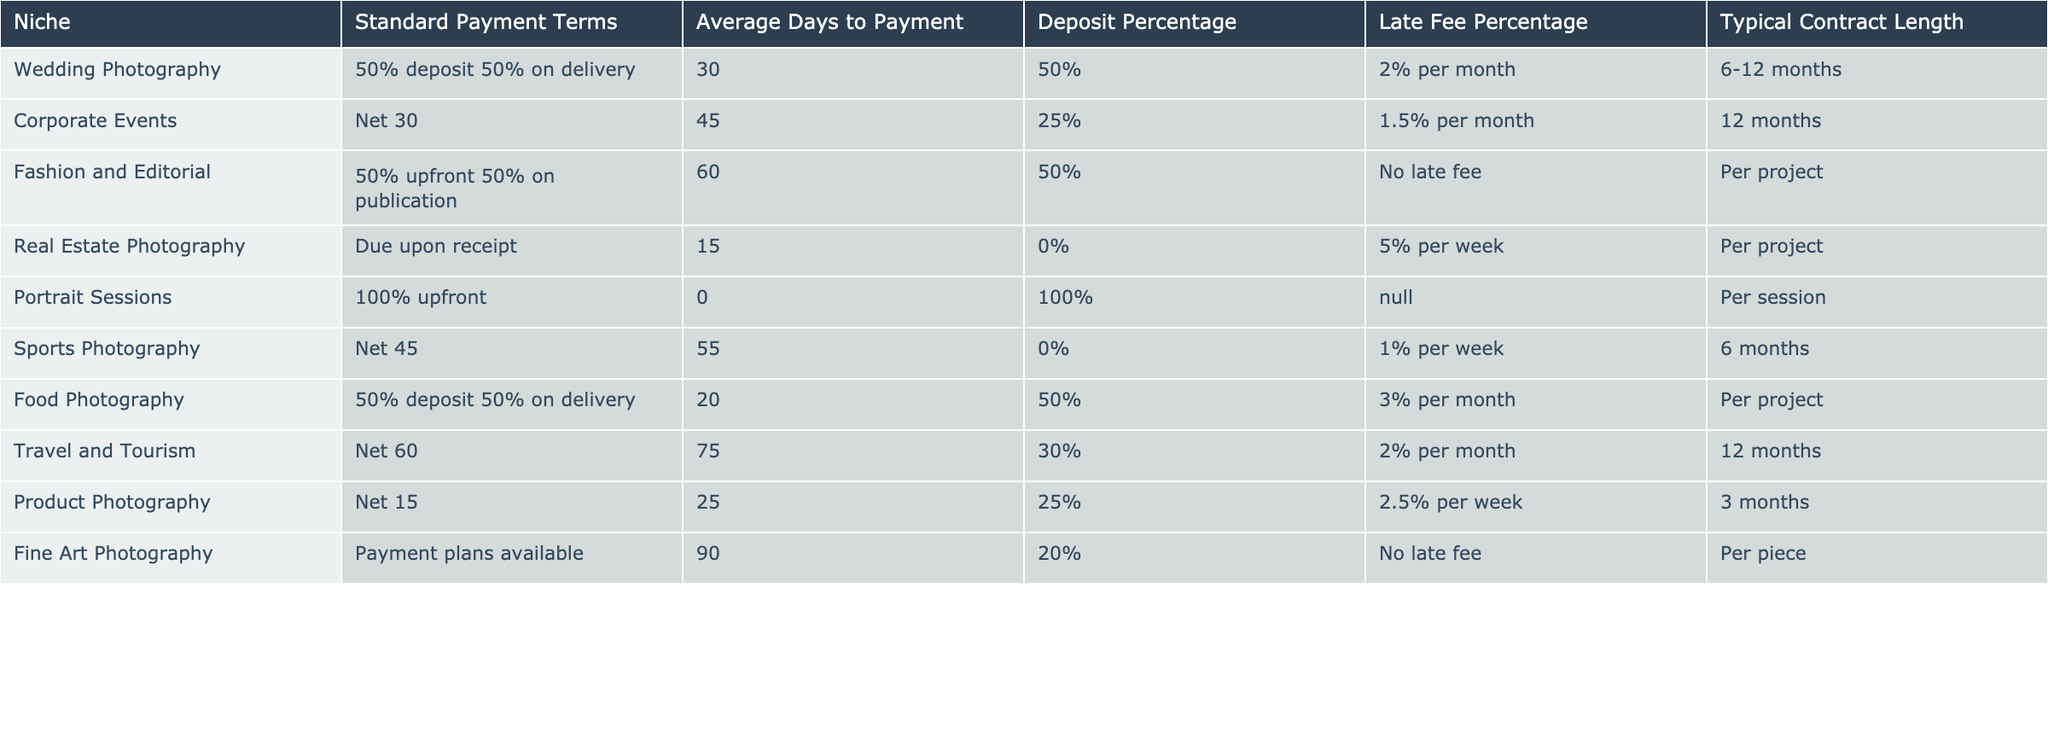What are the standard payment terms for Fashion and Editorial photography? The table lists "50% upfront 50% on publication" under the Standard Payment Terms for Fashion and Editorial photography.
Answer: 50% upfront 50% on publication How many niches require a 100% upfront payment? The table shows that there is only one niche, Portrait Sessions, that requires a 100% upfront payment, as indicated in the Standard Payment Terms column.
Answer: 1 What is the average days to payment for Corporate Events and Travel and Tourism photography? The average days to payment for Corporate Events is 45, and for Travel and Tourism, it is 75. To find the average, we calculate (45 + 75) / 2 = 60.
Answer: 60 Is it true that Real Estate Photography has a late fee? The table indicates "5% per week" under Late Fee Percentage for Real Estate Photography, meaning they do charge a late fee.
Answer: Yes Which niche has the longest typical contract length, and how long is it? By examining the Typical Contract Length column, Travel and Tourism and Corporate Events both show a contract length of 12 months, which is the longest.
Answer: Travel and Tourism and Corporate Events; 12 months What is the difference in Average Days to Payment between Fashion and Editorial and Sports Photography? The Average Days to Payment for Fashion and Editorial photography is 60, and for Sports Photography, it is 55. The difference is 60 - 55 = 5.
Answer: 5 Which niche has the highest percentage for deposits collected upfront? The table indicates that Portrait Sessions have a deposit percentage of 100%, which is the highest when comparing all the niches.
Answer: Portrait Sessions Is there any photography niche that offers no late fee? Yes, both Fashion and Editorial and Fine Art Photography have "No late fee" listed in the Late Fee Percentage column, indicating they do not charge a late fee.
Answer: Yes How would you compare the deposit percentages of Wedding Photography and Food Photography? Wedding Photography has a deposit percentage of 50%, while Food Photography also has a deposit percentage of 50%. Hence, they are the same.
Answer: They are the same; 50% If a photographer wants quick payment, which niche should they consider based on the Average Days to Payment? The best option would be Real Estate Photography, which has the lowest Average Days to Payment at 15.
Answer: Real Estate Photography 